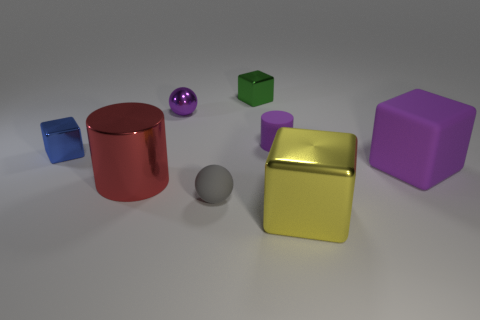How many big shiny cylinders have the same color as the metallic sphere?
Provide a succinct answer. 0. Does the metal ball have the same color as the cube to the right of the big yellow shiny thing?
Ensure brevity in your answer.  Yes. Is the number of small things less than the number of things?
Give a very brief answer. Yes. Are there more purple cylinders that are in front of the yellow object than purple matte cubes that are behind the green block?
Give a very brief answer. No. Does the tiny gray sphere have the same material as the large purple cube?
Keep it short and to the point. Yes. What number of purple blocks are to the right of the tiny matte object that is behind the big rubber object?
Your response must be concise. 1. Is the color of the cylinder behind the big metallic cylinder the same as the rubber cube?
Make the answer very short. Yes. How many things are either metallic blocks or blocks on the right side of the yellow shiny cube?
Offer a very short reply. 4. There is a small matte thing that is in front of the small purple matte cylinder; does it have the same shape as the purple object to the left of the gray matte sphere?
Offer a terse response. Yes. Is there anything else of the same color as the large shiny block?
Give a very brief answer. No. 